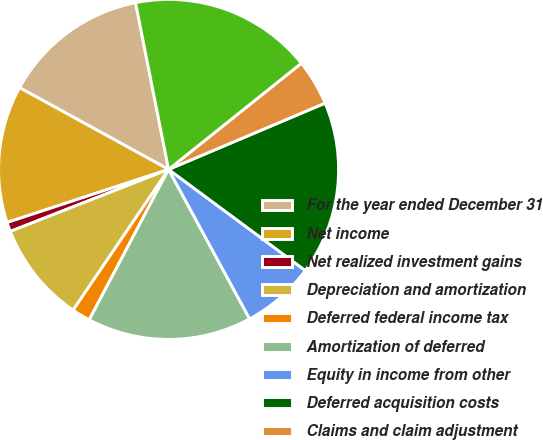Convert chart. <chart><loc_0><loc_0><loc_500><loc_500><pie_chart><fcel>For the year ended December 31<fcel>Net income<fcel>Net realized investment gains<fcel>Depreciation and amortization<fcel>Deferred federal income tax<fcel>Amortization of deferred<fcel>Equity in income from other<fcel>Deferred acquisition costs<fcel>Claims and claim adjustment<fcel>Proceeds from sales of<nl><fcel>13.9%<fcel>13.04%<fcel>0.89%<fcel>9.57%<fcel>1.76%<fcel>15.64%<fcel>6.96%<fcel>16.51%<fcel>4.36%<fcel>17.38%<nl></chart> 